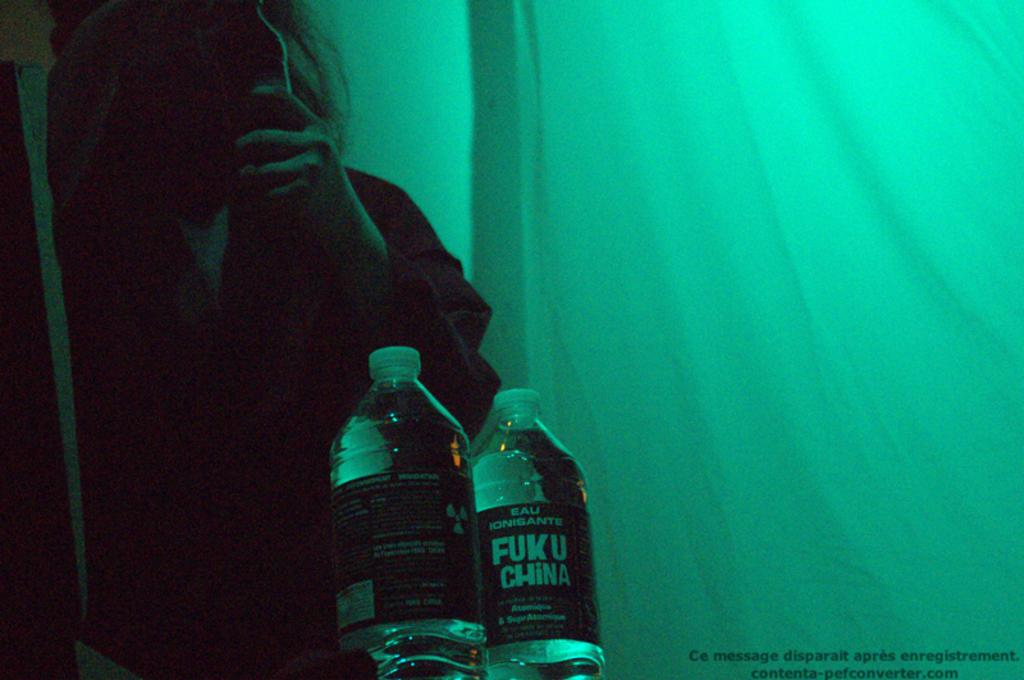<image>
Present a compact description of the photo's key features. A person is standing behind two bottles of water from Fuku China. 